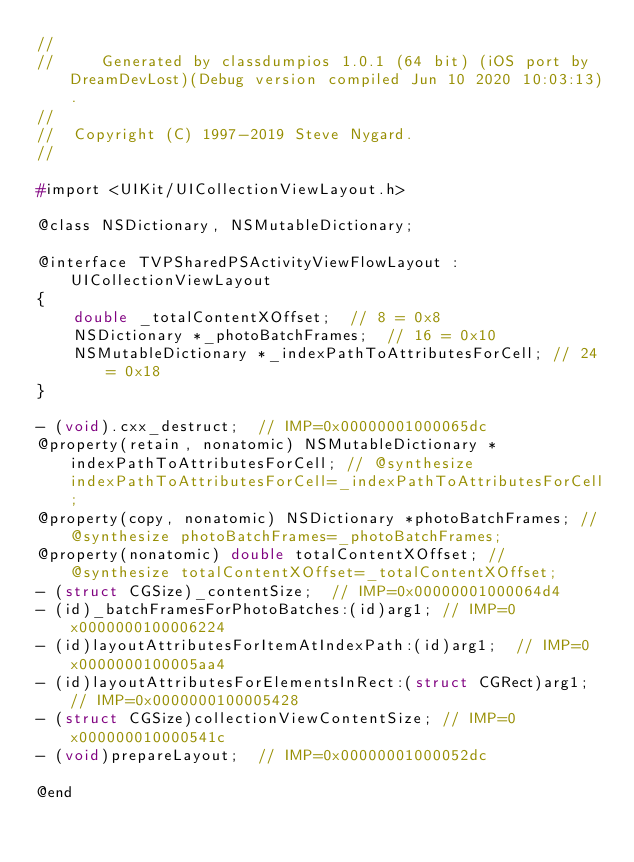<code> <loc_0><loc_0><loc_500><loc_500><_C_>//
//     Generated by classdumpios 1.0.1 (64 bit) (iOS port by DreamDevLost)(Debug version compiled Jun 10 2020 10:03:13).
//
//  Copyright (C) 1997-2019 Steve Nygard.
//

#import <UIKit/UICollectionViewLayout.h>

@class NSDictionary, NSMutableDictionary;

@interface TVPSharedPSActivityViewFlowLayout : UICollectionViewLayout
{
    double _totalContentXOffset;	// 8 = 0x8
    NSDictionary *_photoBatchFrames;	// 16 = 0x10
    NSMutableDictionary *_indexPathToAttributesForCell;	// 24 = 0x18
}

- (void).cxx_destruct;	// IMP=0x00000001000065dc
@property(retain, nonatomic) NSMutableDictionary *indexPathToAttributesForCell; // @synthesize indexPathToAttributesForCell=_indexPathToAttributesForCell;
@property(copy, nonatomic) NSDictionary *photoBatchFrames; // @synthesize photoBatchFrames=_photoBatchFrames;
@property(nonatomic) double totalContentXOffset; // @synthesize totalContentXOffset=_totalContentXOffset;
- (struct CGSize)_contentSize;	// IMP=0x00000001000064d4
- (id)_batchFramesForPhotoBatches:(id)arg1;	// IMP=0x0000000100006224
- (id)layoutAttributesForItemAtIndexPath:(id)arg1;	// IMP=0x0000000100005aa4
- (id)layoutAttributesForElementsInRect:(struct CGRect)arg1;	// IMP=0x0000000100005428
- (struct CGSize)collectionViewContentSize;	// IMP=0x000000010000541c
- (void)prepareLayout;	// IMP=0x00000001000052dc

@end

</code> 